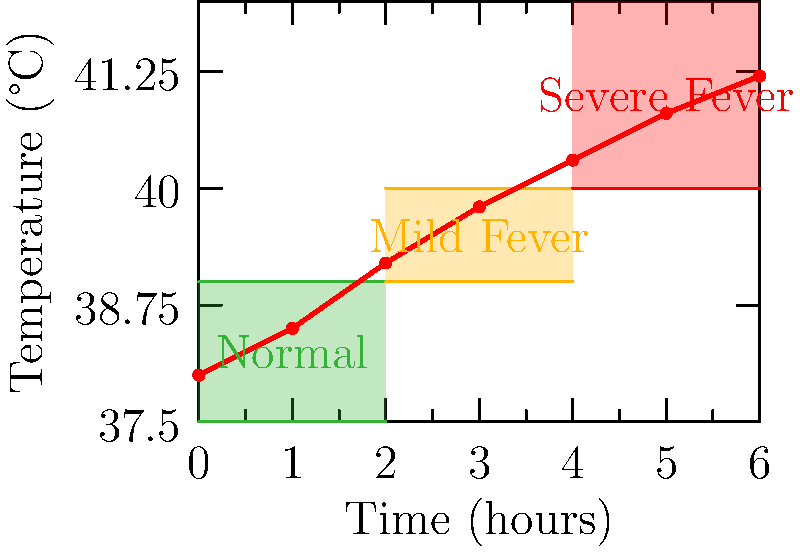Based on the temperature curve shown in the diagram, at what point (in hours) does the cat's post-operative temperature indicate a transition from a mild fever to a severe fever, potentially signaling a serious complication? To determine when the cat's temperature transitions from a mild to a severe fever, we need to follow these steps:

1. Identify the temperature ranges:
   - Normal: 37.5°C to 39°C
   - Mild fever: 39°C to 40°C
   - Severe fever: Above 40°C

2. Analyze the temperature curve:
   - The curve starts in the normal range at 0 hours.
   - It enters the mild fever range around 2 hours post-operation.
   - The curve continues to rise steadily.

3. Locate the transition point:
   - The curve crosses the 40°C line, entering the severe fever range.
   - This occurs between 4 and 5 hours on the time axis.

4. Estimate the exact time:
   - The transition appears to happen closer to the 4-hour mark.
   - By visual approximation, it's around 4.2 to 4.3 hours post-operation.

5. Conclusion:
   The cat's temperature indicates a transition from a mild to a severe fever at approximately 4.3 hours post-operation, signaling a potential serious complication that requires immediate attention.
Answer: 4.3 hours 